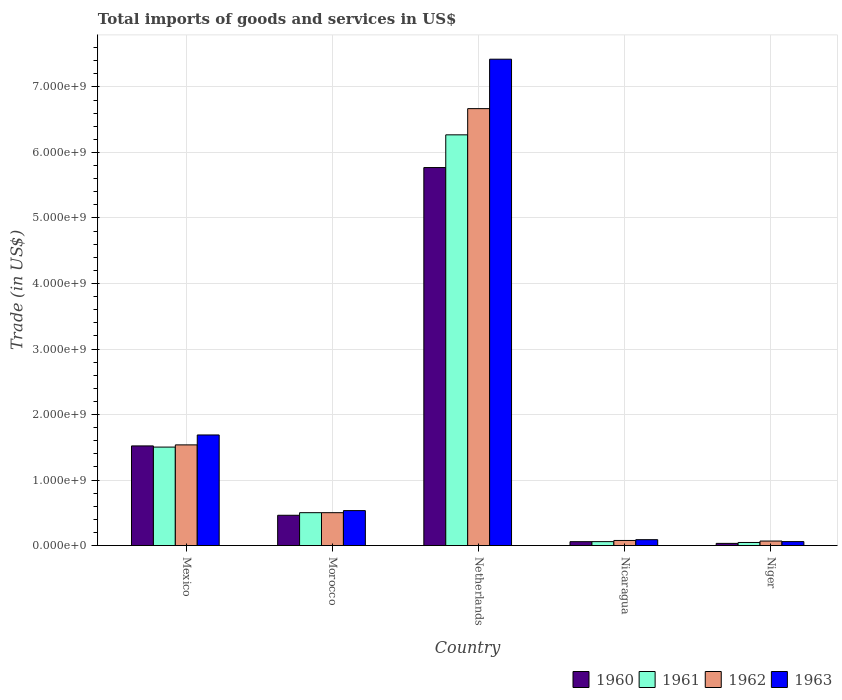How many different coloured bars are there?
Your response must be concise. 4. How many groups of bars are there?
Your response must be concise. 5. Are the number of bars per tick equal to the number of legend labels?
Offer a very short reply. Yes. What is the label of the 2nd group of bars from the left?
Make the answer very short. Morocco. In how many cases, is the number of bars for a given country not equal to the number of legend labels?
Provide a short and direct response. 0. What is the total imports of goods and services in 1963 in Morocco?
Provide a short and direct response. 5.34e+08. Across all countries, what is the maximum total imports of goods and services in 1962?
Keep it short and to the point. 6.67e+09. Across all countries, what is the minimum total imports of goods and services in 1962?
Provide a short and direct response. 6.88e+07. In which country was the total imports of goods and services in 1963 maximum?
Your answer should be compact. Netherlands. In which country was the total imports of goods and services in 1960 minimum?
Make the answer very short. Niger. What is the total total imports of goods and services in 1963 in the graph?
Your answer should be very brief. 9.80e+09. What is the difference between the total imports of goods and services in 1960 in Mexico and that in Netherlands?
Your answer should be very brief. -4.25e+09. What is the difference between the total imports of goods and services in 1963 in Morocco and the total imports of goods and services in 1961 in Mexico?
Offer a terse response. -9.70e+08. What is the average total imports of goods and services in 1961 per country?
Your answer should be very brief. 1.68e+09. What is the difference between the total imports of goods and services of/in 1960 and total imports of goods and services of/in 1962 in Mexico?
Your answer should be very brief. -1.56e+07. In how many countries, is the total imports of goods and services in 1963 greater than 3800000000 US$?
Your response must be concise. 1. What is the ratio of the total imports of goods and services in 1961 in Mexico to that in Nicaragua?
Provide a succinct answer. 25.07. Is the total imports of goods and services in 1961 in Mexico less than that in Netherlands?
Provide a short and direct response. Yes. Is the difference between the total imports of goods and services in 1960 in Morocco and Netherlands greater than the difference between the total imports of goods and services in 1962 in Morocco and Netherlands?
Provide a succinct answer. Yes. What is the difference between the highest and the second highest total imports of goods and services in 1961?
Keep it short and to the point. 1.00e+09. What is the difference between the highest and the lowest total imports of goods and services in 1963?
Offer a terse response. 7.36e+09. In how many countries, is the total imports of goods and services in 1961 greater than the average total imports of goods and services in 1961 taken over all countries?
Keep it short and to the point. 1. Is it the case that in every country, the sum of the total imports of goods and services in 1963 and total imports of goods and services in 1962 is greater than the sum of total imports of goods and services in 1961 and total imports of goods and services in 1960?
Give a very brief answer. No. Is it the case that in every country, the sum of the total imports of goods and services in 1960 and total imports of goods and services in 1963 is greater than the total imports of goods and services in 1962?
Your answer should be very brief. Yes. How many bars are there?
Ensure brevity in your answer.  20. What is the difference between two consecutive major ticks on the Y-axis?
Your response must be concise. 1.00e+09. Where does the legend appear in the graph?
Offer a very short reply. Bottom right. How many legend labels are there?
Provide a short and direct response. 4. How are the legend labels stacked?
Your response must be concise. Horizontal. What is the title of the graph?
Make the answer very short. Total imports of goods and services in US$. What is the label or title of the Y-axis?
Keep it short and to the point. Trade (in US$). What is the Trade (in US$) in 1960 in Mexico?
Your answer should be very brief. 1.52e+09. What is the Trade (in US$) of 1961 in Mexico?
Provide a short and direct response. 1.50e+09. What is the Trade (in US$) in 1962 in Mexico?
Keep it short and to the point. 1.54e+09. What is the Trade (in US$) in 1963 in Mexico?
Keep it short and to the point. 1.69e+09. What is the Trade (in US$) in 1960 in Morocco?
Keep it short and to the point. 4.62e+08. What is the Trade (in US$) of 1961 in Morocco?
Keep it short and to the point. 5.02e+08. What is the Trade (in US$) in 1962 in Morocco?
Your answer should be very brief. 5.02e+08. What is the Trade (in US$) of 1963 in Morocco?
Keep it short and to the point. 5.34e+08. What is the Trade (in US$) of 1960 in Netherlands?
Your answer should be very brief. 5.77e+09. What is the Trade (in US$) of 1961 in Netherlands?
Your answer should be compact. 6.27e+09. What is the Trade (in US$) in 1962 in Netherlands?
Ensure brevity in your answer.  6.67e+09. What is the Trade (in US$) in 1963 in Netherlands?
Keep it short and to the point. 7.42e+09. What is the Trade (in US$) of 1960 in Nicaragua?
Provide a short and direct response. 5.95e+07. What is the Trade (in US$) of 1961 in Nicaragua?
Ensure brevity in your answer.  5.99e+07. What is the Trade (in US$) in 1962 in Nicaragua?
Offer a terse response. 7.78e+07. What is the Trade (in US$) of 1963 in Nicaragua?
Your answer should be very brief. 8.99e+07. What is the Trade (in US$) of 1960 in Niger?
Offer a terse response. 3.33e+07. What is the Trade (in US$) in 1961 in Niger?
Provide a short and direct response. 4.71e+07. What is the Trade (in US$) in 1962 in Niger?
Keep it short and to the point. 6.88e+07. What is the Trade (in US$) of 1963 in Niger?
Make the answer very short. 6.05e+07. Across all countries, what is the maximum Trade (in US$) in 1960?
Provide a succinct answer. 5.77e+09. Across all countries, what is the maximum Trade (in US$) of 1961?
Give a very brief answer. 6.27e+09. Across all countries, what is the maximum Trade (in US$) in 1962?
Make the answer very short. 6.67e+09. Across all countries, what is the maximum Trade (in US$) of 1963?
Ensure brevity in your answer.  7.42e+09. Across all countries, what is the minimum Trade (in US$) of 1960?
Keep it short and to the point. 3.33e+07. Across all countries, what is the minimum Trade (in US$) of 1961?
Provide a short and direct response. 4.71e+07. Across all countries, what is the minimum Trade (in US$) of 1962?
Your response must be concise. 6.88e+07. Across all countries, what is the minimum Trade (in US$) in 1963?
Make the answer very short. 6.05e+07. What is the total Trade (in US$) in 1960 in the graph?
Your response must be concise. 7.85e+09. What is the total Trade (in US$) of 1961 in the graph?
Your answer should be compact. 8.38e+09. What is the total Trade (in US$) of 1962 in the graph?
Give a very brief answer. 8.85e+09. What is the total Trade (in US$) of 1963 in the graph?
Provide a succinct answer. 9.80e+09. What is the difference between the Trade (in US$) of 1960 in Mexico and that in Morocco?
Provide a succinct answer. 1.06e+09. What is the difference between the Trade (in US$) of 1961 in Mexico and that in Morocco?
Ensure brevity in your answer.  1.00e+09. What is the difference between the Trade (in US$) in 1962 in Mexico and that in Morocco?
Ensure brevity in your answer.  1.03e+09. What is the difference between the Trade (in US$) in 1963 in Mexico and that in Morocco?
Give a very brief answer. 1.15e+09. What is the difference between the Trade (in US$) of 1960 in Mexico and that in Netherlands?
Your response must be concise. -4.25e+09. What is the difference between the Trade (in US$) of 1961 in Mexico and that in Netherlands?
Make the answer very short. -4.77e+09. What is the difference between the Trade (in US$) in 1962 in Mexico and that in Netherlands?
Ensure brevity in your answer.  -5.13e+09. What is the difference between the Trade (in US$) of 1963 in Mexico and that in Netherlands?
Your response must be concise. -5.74e+09. What is the difference between the Trade (in US$) of 1960 in Mexico and that in Nicaragua?
Keep it short and to the point. 1.46e+09. What is the difference between the Trade (in US$) of 1961 in Mexico and that in Nicaragua?
Give a very brief answer. 1.44e+09. What is the difference between the Trade (in US$) in 1962 in Mexico and that in Nicaragua?
Provide a short and direct response. 1.46e+09. What is the difference between the Trade (in US$) in 1963 in Mexico and that in Nicaragua?
Your response must be concise. 1.60e+09. What is the difference between the Trade (in US$) of 1960 in Mexico and that in Niger?
Give a very brief answer. 1.49e+09. What is the difference between the Trade (in US$) of 1961 in Mexico and that in Niger?
Provide a short and direct response. 1.46e+09. What is the difference between the Trade (in US$) in 1962 in Mexico and that in Niger?
Offer a very short reply. 1.47e+09. What is the difference between the Trade (in US$) of 1963 in Mexico and that in Niger?
Give a very brief answer. 1.63e+09. What is the difference between the Trade (in US$) of 1960 in Morocco and that in Netherlands?
Provide a succinct answer. -5.31e+09. What is the difference between the Trade (in US$) of 1961 in Morocco and that in Netherlands?
Your answer should be compact. -5.77e+09. What is the difference between the Trade (in US$) of 1962 in Morocco and that in Netherlands?
Give a very brief answer. -6.17e+09. What is the difference between the Trade (in US$) of 1963 in Morocco and that in Netherlands?
Offer a very short reply. -6.89e+09. What is the difference between the Trade (in US$) in 1960 in Morocco and that in Nicaragua?
Your answer should be compact. 4.03e+08. What is the difference between the Trade (in US$) in 1961 in Morocco and that in Nicaragua?
Give a very brief answer. 4.42e+08. What is the difference between the Trade (in US$) of 1962 in Morocco and that in Nicaragua?
Your answer should be compact. 4.24e+08. What is the difference between the Trade (in US$) in 1963 in Morocco and that in Nicaragua?
Your answer should be compact. 4.44e+08. What is the difference between the Trade (in US$) in 1960 in Morocco and that in Niger?
Ensure brevity in your answer.  4.29e+08. What is the difference between the Trade (in US$) in 1961 in Morocco and that in Niger?
Provide a short and direct response. 4.55e+08. What is the difference between the Trade (in US$) of 1962 in Morocco and that in Niger?
Your answer should be very brief. 4.33e+08. What is the difference between the Trade (in US$) in 1963 in Morocco and that in Niger?
Your answer should be very brief. 4.73e+08. What is the difference between the Trade (in US$) in 1960 in Netherlands and that in Nicaragua?
Offer a very short reply. 5.71e+09. What is the difference between the Trade (in US$) in 1961 in Netherlands and that in Nicaragua?
Ensure brevity in your answer.  6.21e+09. What is the difference between the Trade (in US$) of 1962 in Netherlands and that in Nicaragua?
Your response must be concise. 6.59e+09. What is the difference between the Trade (in US$) of 1963 in Netherlands and that in Nicaragua?
Offer a terse response. 7.33e+09. What is the difference between the Trade (in US$) of 1960 in Netherlands and that in Niger?
Give a very brief answer. 5.74e+09. What is the difference between the Trade (in US$) in 1961 in Netherlands and that in Niger?
Provide a succinct answer. 6.22e+09. What is the difference between the Trade (in US$) in 1962 in Netherlands and that in Niger?
Provide a short and direct response. 6.60e+09. What is the difference between the Trade (in US$) in 1963 in Netherlands and that in Niger?
Provide a short and direct response. 7.36e+09. What is the difference between the Trade (in US$) of 1960 in Nicaragua and that in Niger?
Your response must be concise. 2.62e+07. What is the difference between the Trade (in US$) of 1961 in Nicaragua and that in Niger?
Keep it short and to the point. 1.28e+07. What is the difference between the Trade (in US$) of 1962 in Nicaragua and that in Niger?
Keep it short and to the point. 8.98e+06. What is the difference between the Trade (in US$) of 1963 in Nicaragua and that in Niger?
Offer a terse response. 2.94e+07. What is the difference between the Trade (in US$) in 1960 in Mexico and the Trade (in US$) in 1961 in Morocco?
Give a very brief answer. 1.02e+09. What is the difference between the Trade (in US$) in 1960 in Mexico and the Trade (in US$) in 1962 in Morocco?
Make the answer very short. 1.02e+09. What is the difference between the Trade (in US$) of 1960 in Mexico and the Trade (in US$) of 1963 in Morocco?
Offer a very short reply. 9.87e+08. What is the difference between the Trade (in US$) of 1961 in Mexico and the Trade (in US$) of 1962 in Morocco?
Your answer should be compact. 1.00e+09. What is the difference between the Trade (in US$) of 1961 in Mexico and the Trade (in US$) of 1963 in Morocco?
Provide a short and direct response. 9.70e+08. What is the difference between the Trade (in US$) in 1962 in Mexico and the Trade (in US$) in 1963 in Morocco?
Your response must be concise. 1.00e+09. What is the difference between the Trade (in US$) of 1960 in Mexico and the Trade (in US$) of 1961 in Netherlands?
Your answer should be very brief. -4.75e+09. What is the difference between the Trade (in US$) of 1960 in Mexico and the Trade (in US$) of 1962 in Netherlands?
Give a very brief answer. -5.15e+09. What is the difference between the Trade (in US$) of 1960 in Mexico and the Trade (in US$) of 1963 in Netherlands?
Ensure brevity in your answer.  -5.90e+09. What is the difference between the Trade (in US$) of 1961 in Mexico and the Trade (in US$) of 1962 in Netherlands?
Offer a terse response. -5.17e+09. What is the difference between the Trade (in US$) in 1961 in Mexico and the Trade (in US$) in 1963 in Netherlands?
Your answer should be very brief. -5.92e+09. What is the difference between the Trade (in US$) of 1962 in Mexico and the Trade (in US$) of 1963 in Netherlands?
Keep it short and to the point. -5.89e+09. What is the difference between the Trade (in US$) of 1960 in Mexico and the Trade (in US$) of 1961 in Nicaragua?
Provide a succinct answer. 1.46e+09. What is the difference between the Trade (in US$) of 1960 in Mexico and the Trade (in US$) of 1962 in Nicaragua?
Your answer should be compact. 1.44e+09. What is the difference between the Trade (in US$) in 1960 in Mexico and the Trade (in US$) in 1963 in Nicaragua?
Make the answer very short. 1.43e+09. What is the difference between the Trade (in US$) of 1961 in Mexico and the Trade (in US$) of 1962 in Nicaragua?
Offer a very short reply. 1.43e+09. What is the difference between the Trade (in US$) in 1961 in Mexico and the Trade (in US$) in 1963 in Nicaragua?
Ensure brevity in your answer.  1.41e+09. What is the difference between the Trade (in US$) in 1962 in Mexico and the Trade (in US$) in 1963 in Nicaragua?
Your response must be concise. 1.45e+09. What is the difference between the Trade (in US$) in 1960 in Mexico and the Trade (in US$) in 1961 in Niger?
Your answer should be very brief. 1.47e+09. What is the difference between the Trade (in US$) of 1960 in Mexico and the Trade (in US$) of 1962 in Niger?
Give a very brief answer. 1.45e+09. What is the difference between the Trade (in US$) of 1960 in Mexico and the Trade (in US$) of 1963 in Niger?
Provide a short and direct response. 1.46e+09. What is the difference between the Trade (in US$) of 1961 in Mexico and the Trade (in US$) of 1962 in Niger?
Provide a succinct answer. 1.43e+09. What is the difference between the Trade (in US$) in 1961 in Mexico and the Trade (in US$) in 1963 in Niger?
Ensure brevity in your answer.  1.44e+09. What is the difference between the Trade (in US$) in 1962 in Mexico and the Trade (in US$) in 1963 in Niger?
Your answer should be compact. 1.48e+09. What is the difference between the Trade (in US$) in 1960 in Morocco and the Trade (in US$) in 1961 in Netherlands?
Offer a terse response. -5.81e+09. What is the difference between the Trade (in US$) in 1960 in Morocco and the Trade (in US$) in 1962 in Netherlands?
Offer a very short reply. -6.21e+09. What is the difference between the Trade (in US$) of 1960 in Morocco and the Trade (in US$) of 1963 in Netherlands?
Offer a very short reply. -6.96e+09. What is the difference between the Trade (in US$) in 1961 in Morocco and the Trade (in US$) in 1962 in Netherlands?
Your response must be concise. -6.17e+09. What is the difference between the Trade (in US$) in 1961 in Morocco and the Trade (in US$) in 1963 in Netherlands?
Your answer should be compact. -6.92e+09. What is the difference between the Trade (in US$) in 1962 in Morocco and the Trade (in US$) in 1963 in Netherlands?
Your response must be concise. -6.92e+09. What is the difference between the Trade (in US$) in 1960 in Morocco and the Trade (in US$) in 1961 in Nicaragua?
Your answer should be very brief. 4.02e+08. What is the difference between the Trade (in US$) of 1960 in Morocco and the Trade (in US$) of 1962 in Nicaragua?
Your answer should be compact. 3.85e+08. What is the difference between the Trade (in US$) of 1960 in Morocco and the Trade (in US$) of 1963 in Nicaragua?
Provide a short and direct response. 3.72e+08. What is the difference between the Trade (in US$) of 1961 in Morocco and the Trade (in US$) of 1962 in Nicaragua?
Give a very brief answer. 4.24e+08. What is the difference between the Trade (in US$) in 1961 in Morocco and the Trade (in US$) in 1963 in Nicaragua?
Keep it short and to the point. 4.12e+08. What is the difference between the Trade (in US$) in 1962 in Morocco and the Trade (in US$) in 1963 in Nicaragua?
Your response must be concise. 4.12e+08. What is the difference between the Trade (in US$) in 1960 in Morocco and the Trade (in US$) in 1961 in Niger?
Give a very brief answer. 4.15e+08. What is the difference between the Trade (in US$) in 1960 in Morocco and the Trade (in US$) in 1962 in Niger?
Your response must be concise. 3.94e+08. What is the difference between the Trade (in US$) of 1960 in Morocco and the Trade (in US$) of 1963 in Niger?
Provide a short and direct response. 4.02e+08. What is the difference between the Trade (in US$) in 1961 in Morocco and the Trade (in US$) in 1962 in Niger?
Ensure brevity in your answer.  4.33e+08. What is the difference between the Trade (in US$) of 1961 in Morocco and the Trade (in US$) of 1963 in Niger?
Offer a very short reply. 4.41e+08. What is the difference between the Trade (in US$) of 1962 in Morocco and the Trade (in US$) of 1963 in Niger?
Your response must be concise. 4.41e+08. What is the difference between the Trade (in US$) of 1960 in Netherlands and the Trade (in US$) of 1961 in Nicaragua?
Offer a terse response. 5.71e+09. What is the difference between the Trade (in US$) in 1960 in Netherlands and the Trade (in US$) in 1962 in Nicaragua?
Ensure brevity in your answer.  5.69e+09. What is the difference between the Trade (in US$) in 1960 in Netherlands and the Trade (in US$) in 1963 in Nicaragua?
Ensure brevity in your answer.  5.68e+09. What is the difference between the Trade (in US$) in 1961 in Netherlands and the Trade (in US$) in 1962 in Nicaragua?
Provide a short and direct response. 6.19e+09. What is the difference between the Trade (in US$) in 1961 in Netherlands and the Trade (in US$) in 1963 in Nicaragua?
Offer a very short reply. 6.18e+09. What is the difference between the Trade (in US$) of 1962 in Netherlands and the Trade (in US$) of 1963 in Nicaragua?
Your response must be concise. 6.58e+09. What is the difference between the Trade (in US$) of 1960 in Netherlands and the Trade (in US$) of 1961 in Niger?
Your answer should be very brief. 5.72e+09. What is the difference between the Trade (in US$) of 1960 in Netherlands and the Trade (in US$) of 1962 in Niger?
Provide a succinct answer. 5.70e+09. What is the difference between the Trade (in US$) of 1960 in Netherlands and the Trade (in US$) of 1963 in Niger?
Your response must be concise. 5.71e+09. What is the difference between the Trade (in US$) of 1961 in Netherlands and the Trade (in US$) of 1962 in Niger?
Your answer should be very brief. 6.20e+09. What is the difference between the Trade (in US$) in 1961 in Netherlands and the Trade (in US$) in 1963 in Niger?
Provide a short and direct response. 6.21e+09. What is the difference between the Trade (in US$) in 1962 in Netherlands and the Trade (in US$) in 1963 in Niger?
Your answer should be compact. 6.61e+09. What is the difference between the Trade (in US$) of 1960 in Nicaragua and the Trade (in US$) of 1961 in Niger?
Make the answer very short. 1.23e+07. What is the difference between the Trade (in US$) in 1960 in Nicaragua and the Trade (in US$) in 1962 in Niger?
Give a very brief answer. -9.39e+06. What is the difference between the Trade (in US$) of 1960 in Nicaragua and the Trade (in US$) of 1963 in Niger?
Offer a very short reply. -1.06e+06. What is the difference between the Trade (in US$) in 1961 in Nicaragua and the Trade (in US$) in 1962 in Niger?
Your answer should be very brief. -8.90e+06. What is the difference between the Trade (in US$) of 1961 in Nicaragua and the Trade (in US$) of 1963 in Niger?
Keep it short and to the point. -5.73e+05. What is the difference between the Trade (in US$) of 1962 in Nicaragua and the Trade (in US$) of 1963 in Niger?
Give a very brief answer. 1.73e+07. What is the average Trade (in US$) in 1960 per country?
Provide a succinct answer. 1.57e+09. What is the average Trade (in US$) in 1961 per country?
Provide a short and direct response. 1.68e+09. What is the average Trade (in US$) of 1962 per country?
Your answer should be very brief. 1.77e+09. What is the average Trade (in US$) in 1963 per country?
Offer a very short reply. 1.96e+09. What is the difference between the Trade (in US$) of 1960 and Trade (in US$) of 1961 in Mexico?
Your response must be concise. 1.78e+07. What is the difference between the Trade (in US$) of 1960 and Trade (in US$) of 1962 in Mexico?
Make the answer very short. -1.56e+07. What is the difference between the Trade (in US$) of 1960 and Trade (in US$) of 1963 in Mexico?
Offer a very short reply. -1.67e+08. What is the difference between the Trade (in US$) in 1961 and Trade (in US$) in 1962 in Mexico?
Your answer should be compact. -3.34e+07. What is the difference between the Trade (in US$) of 1961 and Trade (in US$) of 1963 in Mexico?
Your answer should be very brief. -1.85e+08. What is the difference between the Trade (in US$) of 1962 and Trade (in US$) of 1963 in Mexico?
Provide a succinct answer. -1.52e+08. What is the difference between the Trade (in US$) in 1960 and Trade (in US$) in 1961 in Morocco?
Offer a very short reply. -3.95e+07. What is the difference between the Trade (in US$) in 1960 and Trade (in US$) in 1962 in Morocco?
Offer a terse response. -3.95e+07. What is the difference between the Trade (in US$) in 1960 and Trade (in US$) in 1963 in Morocco?
Ensure brevity in your answer.  -7.11e+07. What is the difference between the Trade (in US$) of 1961 and Trade (in US$) of 1962 in Morocco?
Offer a terse response. 0. What is the difference between the Trade (in US$) in 1961 and Trade (in US$) in 1963 in Morocco?
Ensure brevity in your answer.  -3.16e+07. What is the difference between the Trade (in US$) of 1962 and Trade (in US$) of 1963 in Morocco?
Give a very brief answer. -3.16e+07. What is the difference between the Trade (in US$) of 1960 and Trade (in US$) of 1961 in Netherlands?
Provide a succinct answer. -4.99e+08. What is the difference between the Trade (in US$) in 1960 and Trade (in US$) in 1962 in Netherlands?
Offer a terse response. -8.99e+08. What is the difference between the Trade (in US$) of 1960 and Trade (in US$) of 1963 in Netherlands?
Offer a terse response. -1.65e+09. What is the difference between the Trade (in US$) of 1961 and Trade (in US$) of 1962 in Netherlands?
Make the answer very short. -4.00e+08. What is the difference between the Trade (in US$) of 1961 and Trade (in US$) of 1963 in Netherlands?
Your response must be concise. -1.15e+09. What is the difference between the Trade (in US$) of 1962 and Trade (in US$) of 1963 in Netherlands?
Your response must be concise. -7.54e+08. What is the difference between the Trade (in US$) in 1960 and Trade (in US$) in 1961 in Nicaragua?
Provide a short and direct response. -4.83e+05. What is the difference between the Trade (in US$) in 1960 and Trade (in US$) in 1962 in Nicaragua?
Give a very brief answer. -1.84e+07. What is the difference between the Trade (in US$) in 1960 and Trade (in US$) in 1963 in Nicaragua?
Offer a very short reply. -3.05e+07. What is the difference between the Trade (in US$) in 1961 and Trade (in US$) in 1962 in Nicaragua?
Offer a very short reply. -1.79e+07. What is the difference between the Trade (in US$) of 1961 and Trade (in US$) of 1963 in Nicaragua?
Your answer should be compact. -3.00e+07. What is the difference between the Trade (in US$) in 1962 and Trade (in US$) in 1963 in Nicaragua?
Offer a terse response. -1.21e+07. What is the difference between the Trade (in US$) of 1960 and Trade (in US$) of 1961 in Niger?
Provide a succinct answer. -1.39e+07. What is the difference between the Trade (in US$) in 1960 and Trade (in US$) in 1962 in Niger?
Offer a very short reply. -3.56e+07. What is the difference between the Trade (in US$) of 1960 and Trade (in US$) of 1963 in Niger?
Keep it short and to the point. -2.72e+07. What is the difference between the Trade (in US$) in 1961 and Trade (in US$) in 1962 in Niger?
Your answer should be compact. -2.17e+07. What is the difference between the Trade (in US$) of 1961 and Trade (in US$) of 1963 in Niger?
Your answer should be compact. -1.34e+07. What is the difference between the Trade (in US$) of 1962 and Trade (in US$) of 1963 in Niger?
Provide a short and direct response. 8.33e+06. What is the ratio of the Trade (in US$) of 1960 in Mexico to that in Morocco?
Offer a very short reply. 3.29. What is the ratio of the Trade (in US$) of 1961 in Mexico to that in Morocco?
Your answer should be very brief. 2.99. What is the ratio of the Trade (in US$) in 1962 in Mexico to that in Morocco?
Make the answer very short. 3.06. What is the ratio of the Trade (in US$) in 1963 in Mexico to that in Morocco?
Give a very brief answer. 3.16. What is the ratio of the Trade (in US$) in 1960 in Mexico to that in Netherlands?
Your answer should be compact. 0.26. What is the ratio of the Trade (in US$) of 1961 in Mexico to that in Netherlands?
Make the answer very short. 0.24. What is the ratio of the Trade (in US$) of 1962 in Mexico to that in Netherlands?
Provide a short and direct response. 0.23. What is the ratio of the Trade (in US$) in 1963 in Mexico to that in Netherlands?
Your answer should be compact. 0.23. What is the ratio of the Trade (in US$) in 1960 in Mexico to that in Nicaragua?
Provide a short and direct response. 25.58. What is the ratio of the Trade (in US$) of 1961 in Mexico to that in Nicaragua?
Offer a very short reply. 25.07. What is the ratio of the Trade (in US$) in 1962 in Mexico to that in Nicaragua?
Keep it short and to the point. 19.74. What is the ratio of the Trade (in US$) of 1963 in Mexico to that in Nicaragua?
Give a very brief answer. 18.77. What is the ratio of the Trade (in US$) of 1960 in Mexico to that in Niger?
Offer a very short reply. 45.69. What is the ratio of the Trade (in US$) of 1961 in Mexico to that in Niger?
Make the answer very short. 31.88. What is the ratio of the Trade (in US$) of 1962 in Mexico to that in Niger?
Offer a very short reply. 22.32. What is the ratio of the Trade (in US$) in 1963 in Mexico to that in Niger?
Keep it short and to the point. 27.89. What is the ratio of the Trade (in US$) of 1960 in Morocco to that in Netherlands?
Offer a terse response. 0.08. What is the ratio of the Trade (in US$) of 1961 in Morocco to that in Netherlands?
Ensure brevity in your answer.  0.08. What is the ratio of the Trade (in US$) of 1962 in Morocco to that in Netherlands?
Your response must be concise. 0.08. What is the ratio of the Trade (in US$) of 1963 in Morocco to that in Netherlands?
Offer a terse response. 0.07. What is the ratio of the Trade (in US$) of 1960 in Morocco to that in Nicaragua?
Make the answer very short. 7.78. What is the ratio of the Trade (in US$) in 1961 in Morocco to that in Nicaragua?
Provide a short and direct response. 8.37. What is the ratio of the Trade (in US$) in 1962 in Morocco to that in Nicaragua?
Your answer should be very brief. 6.45. What is the ratio of the Trade (in US$) in 1963 in Morocco to that in Nicaragua?
Your answer should be very brief. 5.93. What is the ratio of the Trade (in US$) of 1960 in Morocco to that in Niger?
Ensure brevity in your answer.  13.89. What is the ratio of the Trade (in US$) in 1961 in Morocco to that in Niger?
Offer a terse response. 10.65. What is the ratio of the Trade (in US$) of 1962 in Morocco to that in Niger?
Ensure brevity in your answer.  7.29. What is the ratio of the Trade (in US$) in 1963 in Morocco to that in Niger?
Ensure brevity in your answer.  8.82. What is the ratio of the Trade (in US$) of 1960 in Netherlands to that in Nicaragua?
Ensure brevity in your answer.  97.02. What is the ratio of the Trade (in US$) of 1961 in Netherlands to that in Nicaragua?
Provide a succinct answer. 104.57. What is the ratio of the Trade (in US$) of 1962 in Netherlands to that in Nicaragua?
Give a very brief answer. 85.68. What is the ratio of the Trade (in US$) in 1963 in Netherlands to that in Nicaragua?
Make the answer very short. 82.56. What is the ratio of the Trade (in US$) in 1960 in Netherlands to that in Niger?
Provide a short and direct response. 173.31. What is the ratio of the Trade (in US$) in 1961 in Netherlands to that in Niger?
Keep it short and to the point. 132.96. What is the ratio of the Trade (in US$) of 1962 in Netherlands to that in Niger?
Make the answer very short. 96.86. What is the ratio of the Trade (in US$) in 1963 in Netherlands to that in Niger?
Offer a terse response. 122.66. What is the ratio of the Trade (in US$) in 1960 in Nicaragua to that in Niger?
Ensure brevity in your answer.  1.79. What is the ratio of the Trade (in US$) of 1961 in Nicaragua to that in Niger?
Ensure brevity in your answer.  1.27. What is the ratio of the Trade (in US$) in 1962 in Nicaragua to that in Niger?
Ensure brevity in your answer.  1.13. What is the ratio of the Trade (in US$) of 1963 in Nicaragua to that in Niger?
Offer a terse response. 1.49. What is the difference between the highest and the second highest Trade (in US$) in 1960?
Your answer should be compact. 4.25e+09. What is the difference between the highest and the second highest Trade (in US$) of 1961?
Make the answer very short. 4.77e+09. What is the difference between the highest and the second highest Trade (in US$) of 1962?
Your answer should be compact. 5.13e+09. What is the difference between the highest and the second highest Trade (in US$) of 1963?
Provide a short and direct response. 5.74e+09. What is the difference between the highest and the lowest Trade (in US$) of 1960?
Provide a short and direct response. 5.74e+09. What is the difference between the highest and the lowest Trade (in US$) of 1961?
Provide a succinct answer. 6.22e+09. What is the difference between the highest and the lowest Trade (in US$) of 1962?
Provide a short and direct response. 6.60e+09. What is the difference between the highest and the lowest Trade (in US$) of 1963?
Your answer should be very brief. 7.36e+09. 